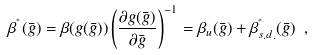Convert formula to latex. <formula><loc_0><loc_0><loc_500><loc_500>\beta ^ { ^ { * } } ( \bar { g } ) = \beta ( g ( \bar { g } ) ) \left ( \frac { \partial g ( \bar { g } ) } { \partial \bar { g } } \right ) ^ { - 1 } = \beta _ { u } ( \bar { g } ) + \beta ^ { ^ { * } } _ { s . d . } ( \bar { g } ) \ ,</formula> 